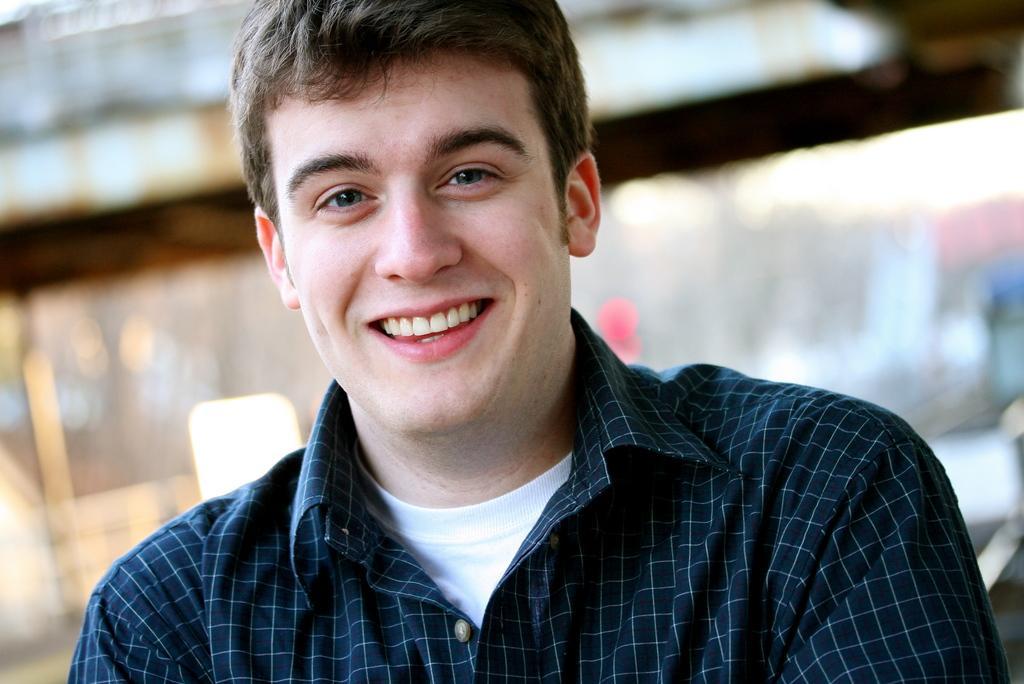Could you give a brief overview of what you see in this image? In the picture I can see a person wearing checked shirt smiling and in the background image is blur. 